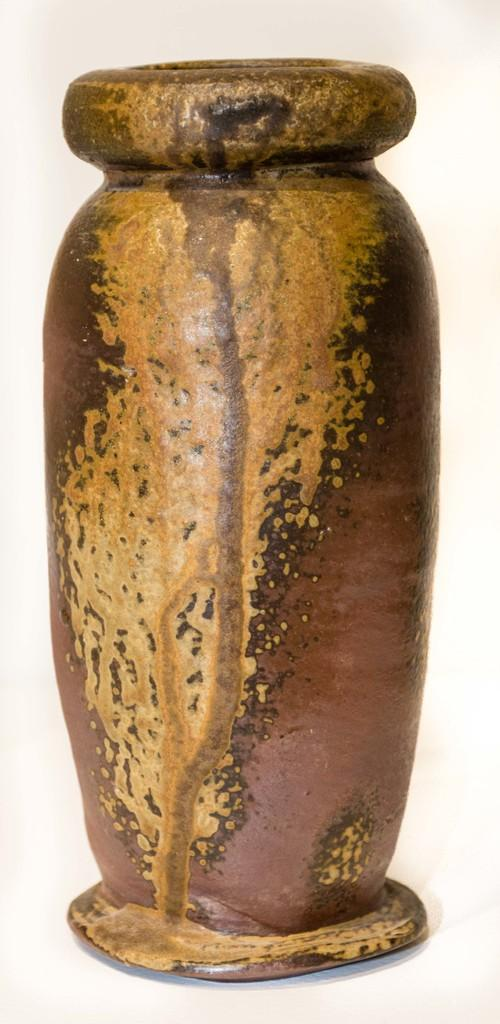What is the main object in the image? There is a pot in the image. What is the name of the patch of grass in the image? There is no patch of grass present in the image; it only features a pot. 